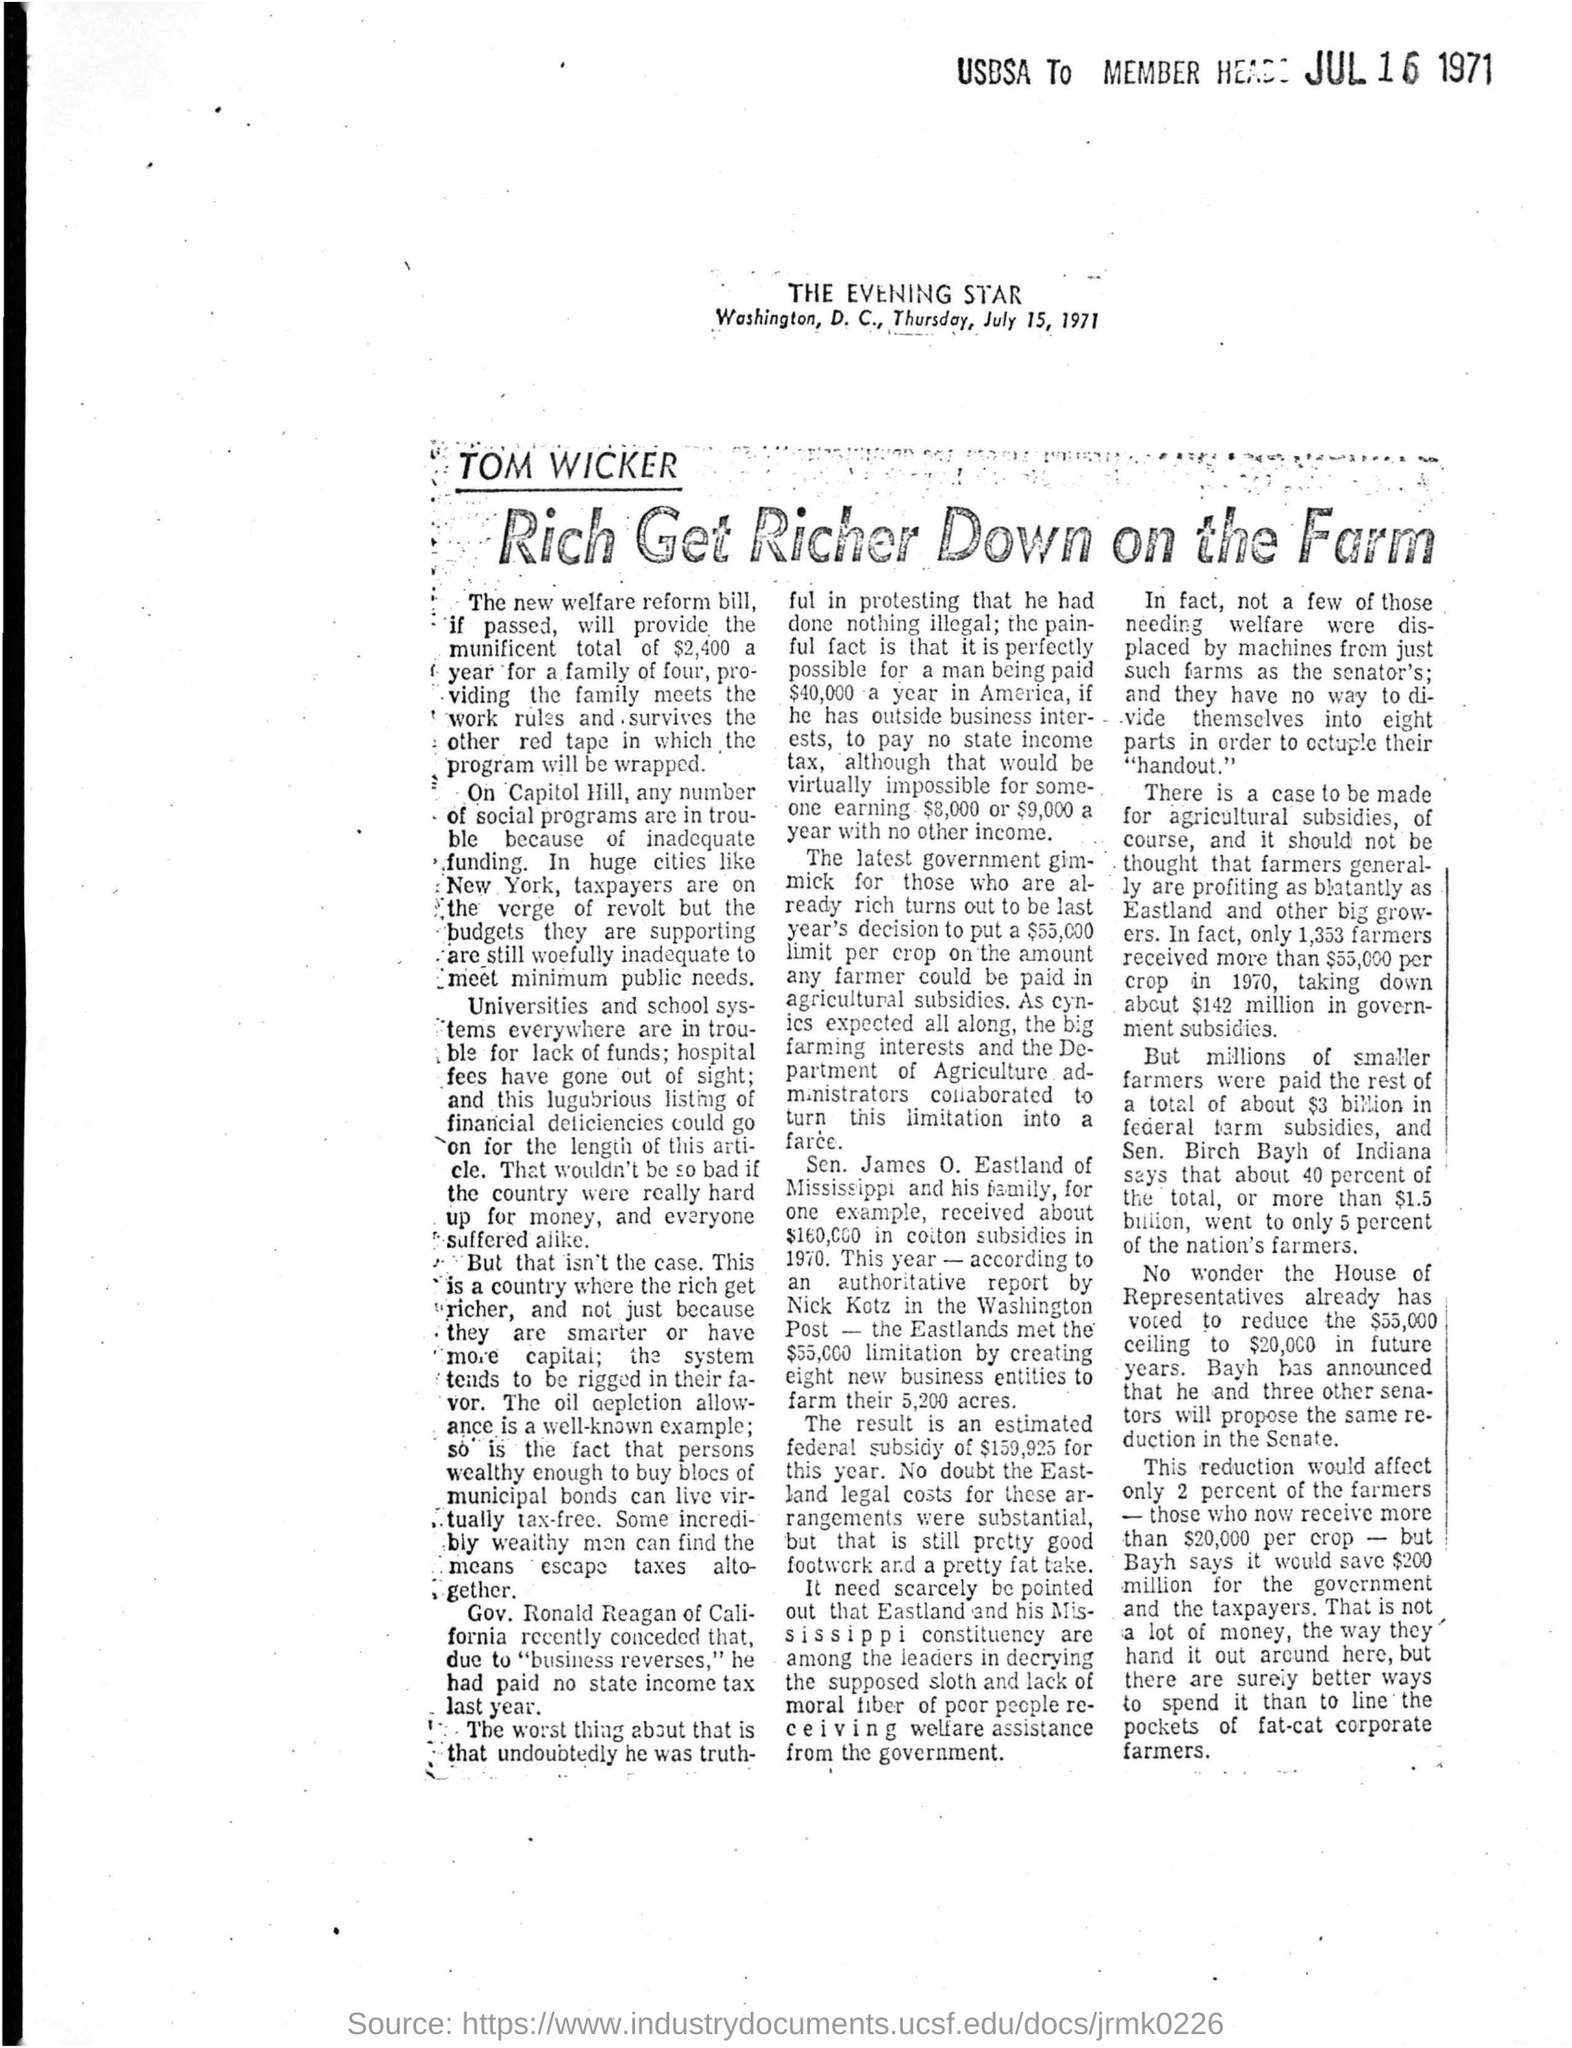Point out several critical features in this image. The article was printed in THE EVENING STAR newspaper. The date on which the printed material was produced is July 15, 1971, as stated in the original text. 